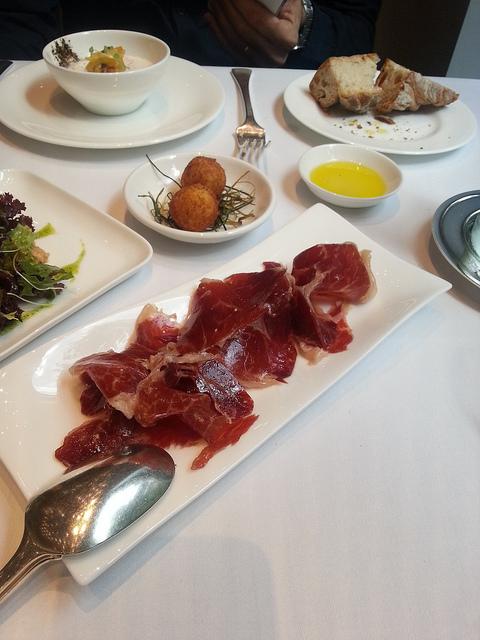Is there an olive oil on the table?
Concise answer only. Yes. Are there candles?
Write a very short answer. No. Is there meat in the picture?
Be succinct. Yes. What color is the table?
Short answer required. White. How many spoons are on the table?
Write a very short answer. 1. 